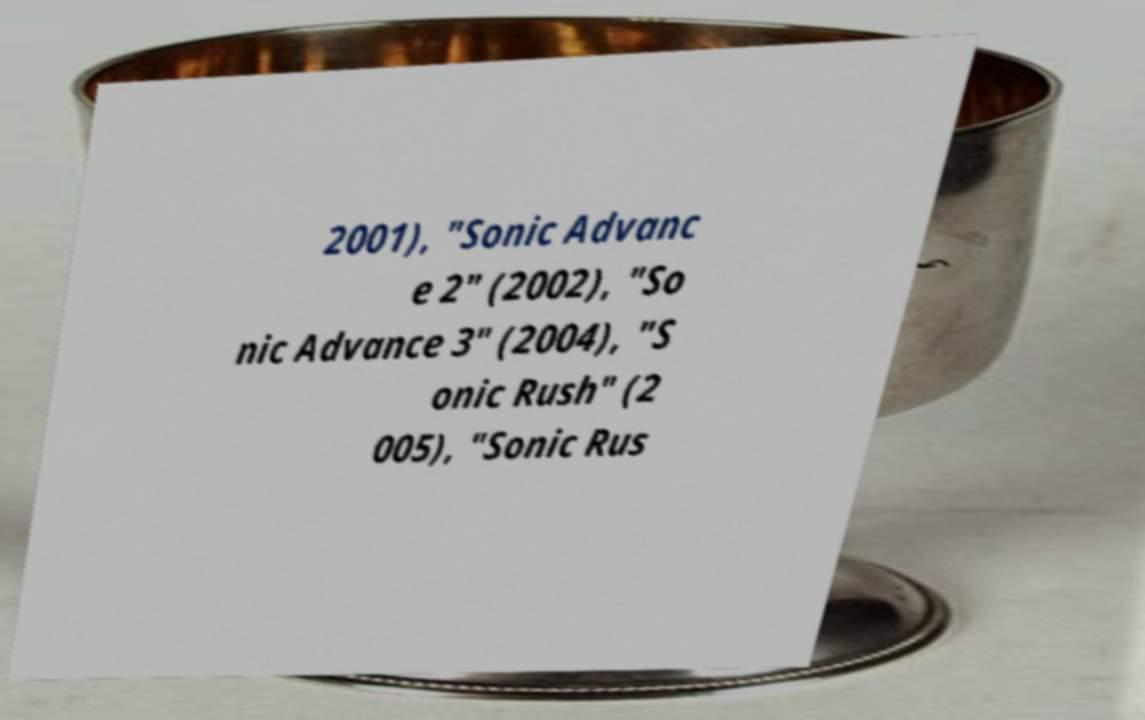Please identify and transcribe the text found in this image. 2001), "Sonic Advanc e 2" (2002), "So nic Advance 3" (2004), "S onic Rush" (2 005), "Sonic Rus 